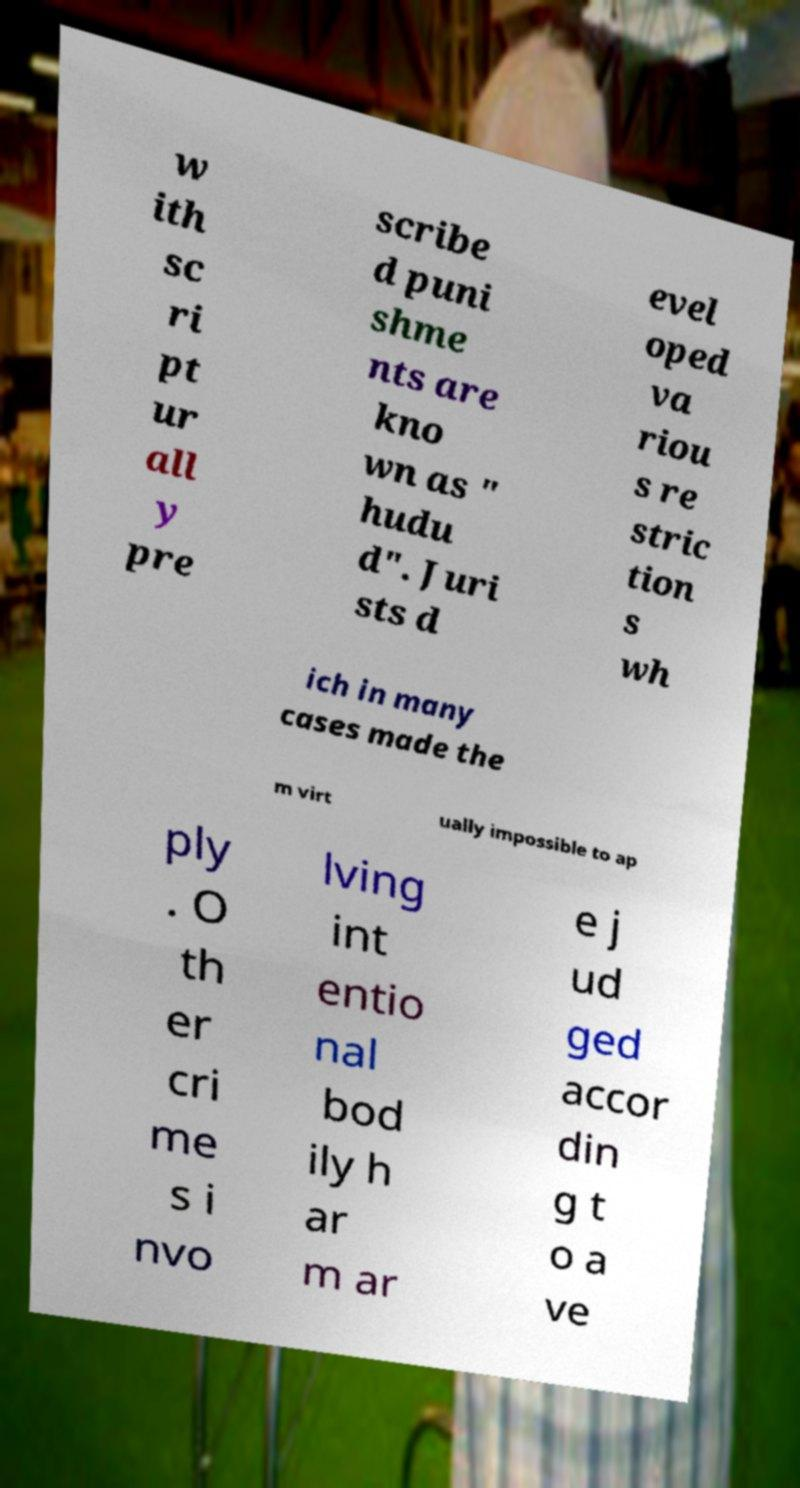Please identify and transcribe the text found in this image. w ith sc ri pt ur all y pre scribe d puni shme nts are kno wn as " hudu d". Juri sts d evel oped va riou s re stric tion s wh ich in many cases made the m virt ually impossible to ap ply . O th er cri me s i nvo lving int entio nal bod ily h ar m ar e j ud ged accor din g t o a ve 